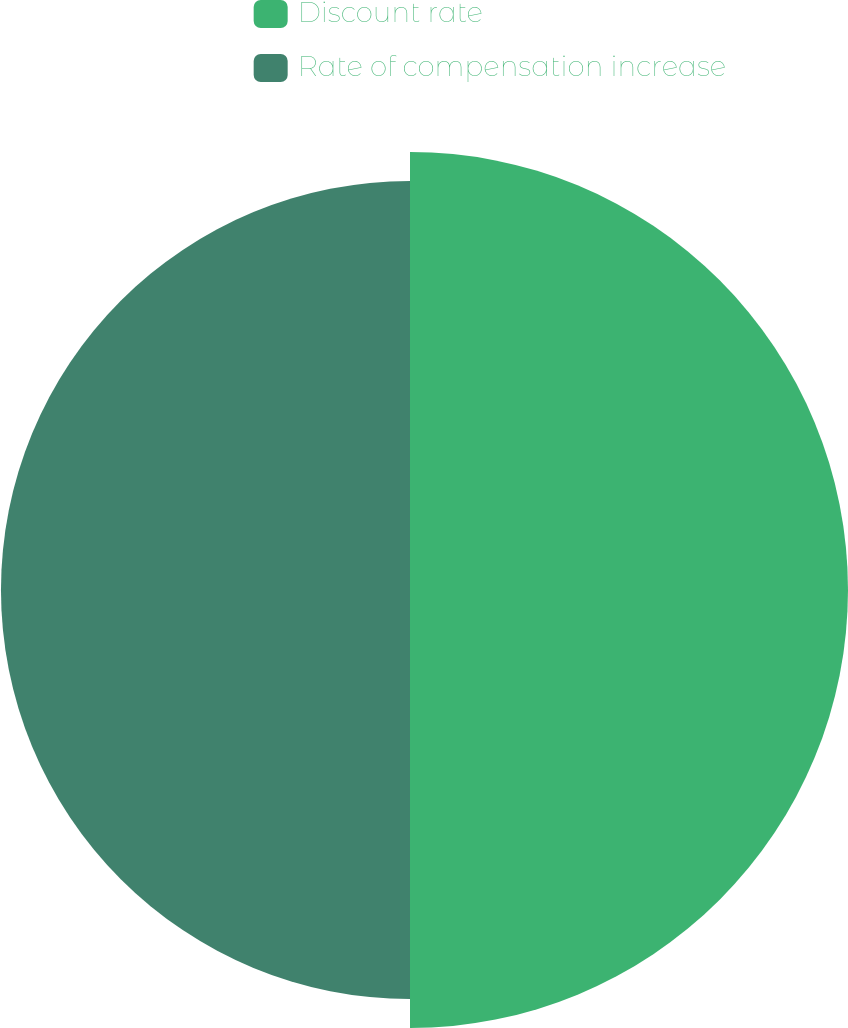Convert chart. <chart><loc_0><loc_0><loc_500><loc_500><pie_chart><fcel>Discount rate<fcel>Rate of compensation increase<nl><fcel>51.71%<fcel>48.29%<nl></chart> 